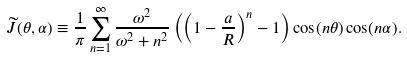<formula> <loc_0><loc_0><loc_500><loc_500>\widetilde { J } ( \theta , \alpha ) \equiv \frac { 1 } { \pi } \sum _ { n = 1 } ^ { \infty } \frac { \omega ^ { 2 } } { \omega ^ { 2 } + n ^ { 2 } } \left ( \left ( 1 - \frac { a } { R } \right ) ^ { n } - 1 \right ) \cos ( n \theta ) \cos ( n \alpha ) .</formula> 